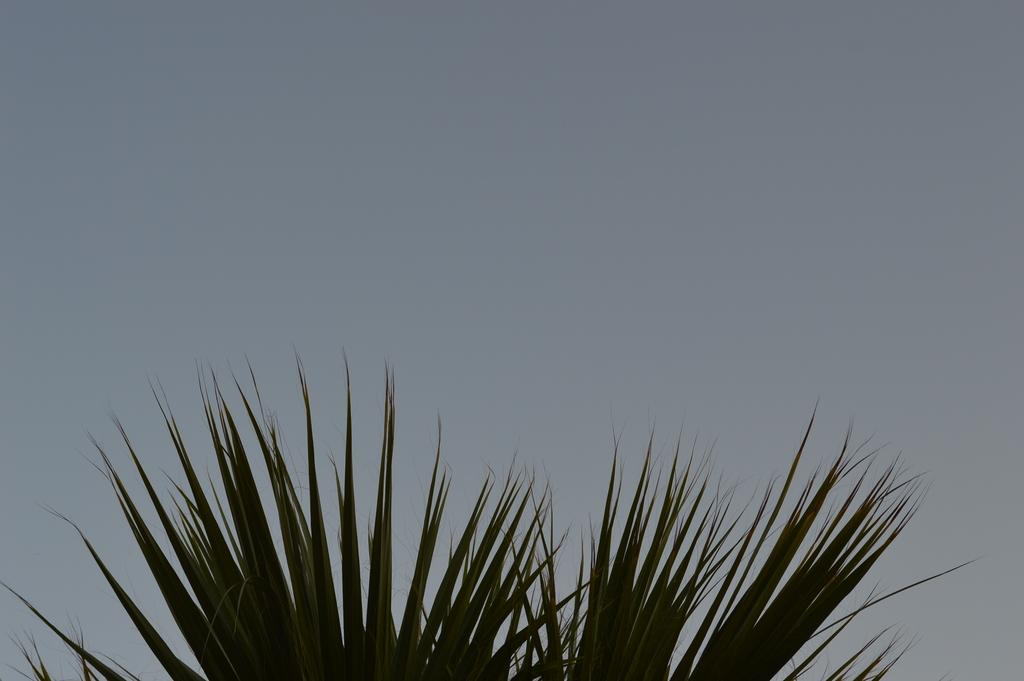What type of natural elements can be seen in the image? Tree leaves can be seen in the image. What part of the natural environment is visible in the image? The sky is visible in the image. What type of clock is visible in the image? There is no clock present in the image. How many sheep can be seen in the image? There are no sheep present in the image. 